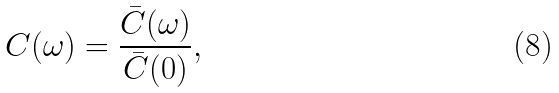Convert formula to latex. <formula><loc_0><loc_0><loc_500><loc_500>C ( \omega ) = \frac { \bar { C } ( \omega ) } { \bar { C } ( 0 ) } ,</formula> 